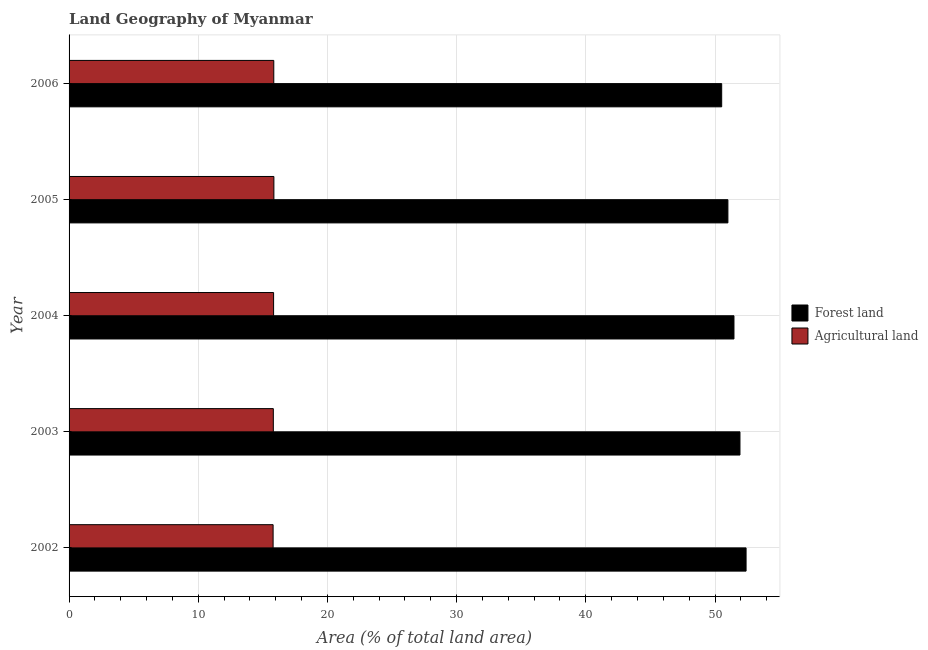In how many cases, is the number of bars for a given year not equal to the number of legend labels?
Offer a terse response. 0. What is the percentage of land area under agriculture in 2002?
Your response must be concise. 15.79. Across all years, what is the maximum percentage of land area under forests?
Ensure brevity in your answer.  52.41. Across all years, what is the minimum percentage of land area under forests?
Ensure brevity in your answer.  50.52. In which year was the percentage of land area under agriculture maximum?
Provide a short and direct response. 2005. What is the total percentage of land area under forests in the graph?
Offer a terse response. 257.32. What is the difference between the percentage of land area under agriculture in 2004 and that in 2005?
Provide a succinct answer. -0.02. What is the difference between the percentage of land area under forests in 2005 and the percentage of land area under agriculture in 2003?
Provide a succinct answer. 35.19. What is the average percentage of land area under agriculture per year?
Your response must be concise. 15.83. In the year 2005, what is the difference between the percentage of land area under agriculture and percentage of land area under forests?
Your response must be concise. -35.14. What is the ratio of the percentage of land area under forests in 2002 to that in 2005?
Make the answer very short. 1.03. Is the difference between the percentage of land area under agriculture in 2004 and 2005 greater than the difference between the percentage of land area under forests in 2004 and 2005?
Provide a short and direct response. No. What is the difference between the highest and the second highest percentage of land area under forests?
Your answer should be very brief. 0.47. What does the 1st bar from the top in 2004 represents?
Make the answer very short. Agricultural land. What does the 2nd bar from the bottom in 2004 represents?
Your answer should be compact. Agricultural land. Are all the bars in the graph horizontal?
Give a very brief answer. Yes. How many years are there in the graph?
Offer a very short reply. 5. What is the difference between two consecutive major ticks on the X-axis?
Your answer should be compact. 10. Are the values on the major ticks of X-axis written in scientific E-notation?
Provide a short and direct response. No. How many legend labels are there?
Offer a very short reply. 2. What is the title of the graph?
Keep it short and to the point. Land Geography of Myanmar. What is the label or title of the X-axis?
Your response must be concise. Area (% of total land area). What is the label or title of the Y-axis?
Offer a terse response. Year. What is the Area (% of total land area) in Forest land in 2002?
Provide a short and direct response. 52.41. What is the Area (% of total land area) in Agricultural land in 2002?
Offer a very short reply. 15.79. What is the Area (% of total land area) of Forest land in 2003?
Provide a short and direct response. 51.93. What is the Area (% of total land area) of Agricultural land in 2003?
Provide a succinct answer. 15.81. What is the Area (% of total land area) of Forest land in 2004?
Your answer should be compact. 51.47. What is the Area (% of total land area) in Agricultural land in 2004?
Your response must be concise. 15.83. What is the Area (% of total land area) of Forest land in 2005?
Offer a terse response. 51. What is the Area (% of total land area) of Agricultural land in 2005?
Provide a short and direct response. 15.86. What is the Area (% of total land area) of Forest land in 2006?
Your response must be concise. 50.52. What is the Area (% of total land area) in Agricultural land in 2006?
Make the answer very short. 15.85. Across all years, what is the maximum Area (% of total land area) in Forest land?
Provide a short and direct response. 52.41. Across all years, what is the maximum Area (% of total land area) in Agricultural land?
Provide a short and direct response. 15.86. Across all years, what is the minimum Area (% of total land area) in Forest land?
Ensure brevity in your answer.  50.52. Across all years, what is the minimum Area (% of total land area) of Agricultural land?
Keep it short and to the point. 15.79. What is the total Area (% of total land area) of Forest land in the graph?
Provide a short and direct response. 257.32. What is the total Area (% of total land area) in Agricultural land in the graph?
Offer a terse response. 79.14. What is the difference between the Area (% of total land area) in Forest land in 2002 and that in 2003?
Provide a succinct answer. 0.47. What is the difference between the Area (% of total land area) in Agricultural land in 2002 and that in 2003?
Keep it short and to the point. -0.02. What is the difference between the Area (% of total land area) of Forest land in 2002 and that in 2004?
Provide a short and direct response. 0.94. What is the difference between the Area (% of total land area) in Agricultural land in 2002 and that in 2004?
Offer a terse response. -0.04. What is the difference between the Area (% of total land area) in Forest land in 2002 and that in 2005?
Your answer should be very brief. 1.41. What is the difference between the Area (% of total land area) in Agricultural land in 2002 and that in 2005?
Your response must be concise. -0.06. What is the difference between the Area (% of total land area) of Forest land in 2002 and that in 2006?
Ensure brevity in your answer.  1.89. What is the difference between the Area (% of total land area) in Agricultural land in 2002 and that in 2006?
Keep it short and to the point. -0.05. What is the difference between the Area (% of total land area) in Forest land in 2003 and that in 2004?
Make the answer very short. 0.46. What is the difference between the Area (% of total land area) in Agricultural land in 2003 and that in 2004?
Make the answer very short. -0.02. What is the difference between the Area (% of total land area) of Forest land in 2003 and that in 2005?
Provide a succinct answer. 0.93. What is the difference between the Area (% of total land area) of Agricultural land in 2003 and that in 2005?
Offer a terse response. -0.04. What is the difference between the Area (% of total land area) of Forest land in 2003 and that in 2006?
Give a very brief answer. 1.42. What is the difference between the Area (% of total land area) of Agricultural land in 2003 and that in 2006?
Your answer should be compact. -0.04. What is the difference between the Area (% of total land area) of Forest land in 2004 and that in 2005?
Give a very brief answer. 0.47. What is the difference between the Area (% of total land area) in Agricultural land in 2004 and that in 2005?
Make the answer very short. -0.02. What is the difference between the Area (% of total land area) of Forest land in 2004 and that in 2006?
Your answer should be compact. 0.95. What is the difference between the Area (% of total land area) in Agricultural land in 2004 and that in 2006?
Your answer should be very brief. -0.01. What is the difference between the Area (% of total land area) in Forest land in 2005 and that in 2006?
Your answer should be compact. 0.48. What is the difference between the Area (% of total land area) of Agricultural land in 2005 and that in 2006?
Provide a succinct answer. 0.01. What is the difference between the Area (% of total land area) in Forest land in 2002 and the Area (% of total land area) in Agricultural land in 2003?
Make the answer very short. 36.59. What is the difference between the Area (% of total land area) of Forest land in 2002 and the Area (% of total land area) of Agricultural land in 2004?
Your response must be concise. 36.57. What is the difference between the Area (% of total land area) in Forest land in 2002 and the Area (% of total land area) in Agricultural land in 2005?
Offer a very short reply. 36.55. What is the difference between the Area (% of total land area) in Forest land in 2002 and the Area (% of total land area) in Agricultural land in 2006?
Your answer should be compact. 36.56. What is the difference between the Area (% of total land area) in Forest land in 2003 and the Area (% of total land area) in Agricultural land in 2004?
Offer a terse response. 36.1. What is the difference between the Area (% of total land area) in Forest land in 2003 and the Area (% of total land area) in Agricultural land in 2005?
Offer a terse response. 36.08. What is the difference between the Area (% of total land area) of Forest land in 2003 and the Area (% of total land area) of Agricultural land in 2006?
Offer a terse response. 36.09. What is the difference between the Area (% of total land area) of Forest land in 2004 and the Area (% of total land area) of Agricultural land in 2005?
Offer a very short reply. 35.61. What is the difference between the Area (% of total land area) in Forest land in 2004 and the Area (% of total land area) in Agricultural land in 2006?
Your answer should be compact. 35.62. What is the difference between the Area (% of total land area) of Forest land in 2005 and the Area (% of total land area) of Agricultural land in 2006?
Make the answer very short. 35.15. What is the average Area (% of total land area) in Forest land per year?
Give a very brief answer. 51.46. What is the average Area (% of total land area) in Agricultural land per year?
Ensure brevity in your answer.  15.83. In the year 2002, what is the difference between the Area (% of total land area) of Forest land and Area (% of total land area) of Agricultural land?
Keep it short and to the point. 36.61. In the year 2003, what is the difference between the Area (% of total land area) in Forest land and Area (% of total land area) in Agricultural land?
Make the answer very short. 36.12. In the year 2004, what is the difference between the Area (% of total land area) in Forest land and Area (% of total land area) in Agricultural land?
Provide a succinct answer. 35.64. In the year 2005, what is the difference between the Area (% of total land area) of Forest land and Area (% of total land area) of Agricultural land?
Your answer should be compact. 35.14. In the year 2006, what is the difference between the Area (% of total land area) of Forest land and Area (% of total land area) of Agricultural land?
Make the answer very short. 34.67. What is the ratio of the Area (% of total land area) in Forest land in 2002 to that in 2003?
Keep it short and to the point. 1.01. What is the ratio of the Area (% of total land area) in Forest land in 2002 to that in 2004?
Your answer should be very brief. 1.02. What is the ratio of the Area (% of total land area) of Agricultural land in 2002 to that in 2004?
Your answer should be compact. 1. What is the ratio of the Area (% of total land area) of Forest land in 2002 to that in 2005?
Provide a short and direct response. 1.03. What is the ratio of the Area (% of total land area) in Forest land in 2002 to that in 2006?
Ensure brevity in your answer.  1.04. What is the ratio of the Area (% of total land area) in Agricultural land in 2002 to that in 2006?
Your answer should be very brief. 1. What is the ratio of the Area (% of total land area) in Agricultural land in 2003 to that in 2004?
Your response must be concise. 1. What is the ratio of the Area (% of total land area) of Forest land in 2003 to that in 2005?
Give a very brief answer. 1.02. What is the ratio of the Area (% of total land area) in Forest land in 2003 to that in 2006?
Make the answer very short. 1.03. What is the ratio of the Area (% of total land area) in Forest land in 2004 to that in 2005?
Your answer should be compact. 1.01. What is the ratio of the Area (% of total land area) of Agricultural land in 2004 to that in 2005?
Your response must be concise. 1. What is the ratio of the Area (% of total land area) of Forest land in 2004 to that in 2006?
Provide a short and direct response. 1.02. What is the ratio of the Area (% of total land area) in Agricultural land in 2004 to that in 2006?
Provide a short and direct response. 1. What is the ratio of the Area (% of total land area) in Forest land in 2005 to that in 2006?
Give a very brief answer. 1.01. What is the ratio of the Area (% of total land area) of Agricultural land in 2005 to that in 2006?
Make the answer very short. 1. What is the difference between the highest and the second highest Area (% of total land area) of Forest land?
Provide a succinct answer. 0.47. What is the difference between the highest and the second highest Area (% of total land area) of Agricultural land?
Make the answer very short. 0.01. What is the difference between the highest and the lowest Area (% of total land area) of Forest land?
Give a very brief answer. 1.89. What is the difference between the highest and the lowest Area (% of total land area) in Agricultural land?
Your answer should be very brief. 0.06. 